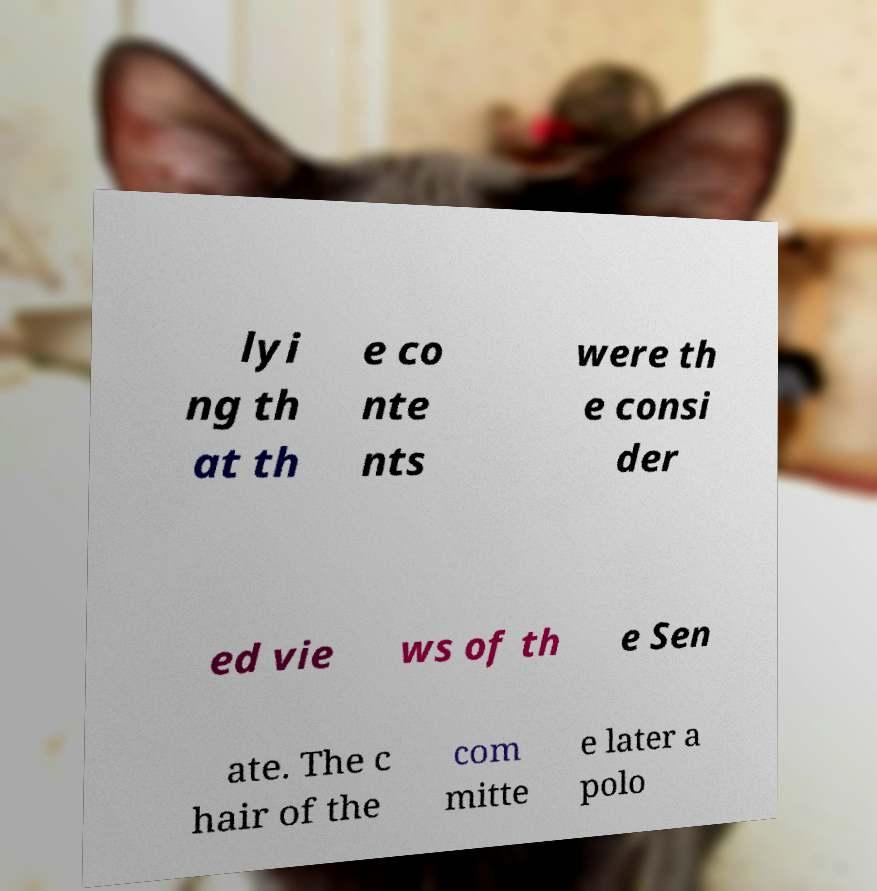Please identify and transcribe the text found in this image. lyi ng th at th e co nte nts were th e consi der ed vie ws of th e Sen ate. The c hair of the com mitte e later a polo 